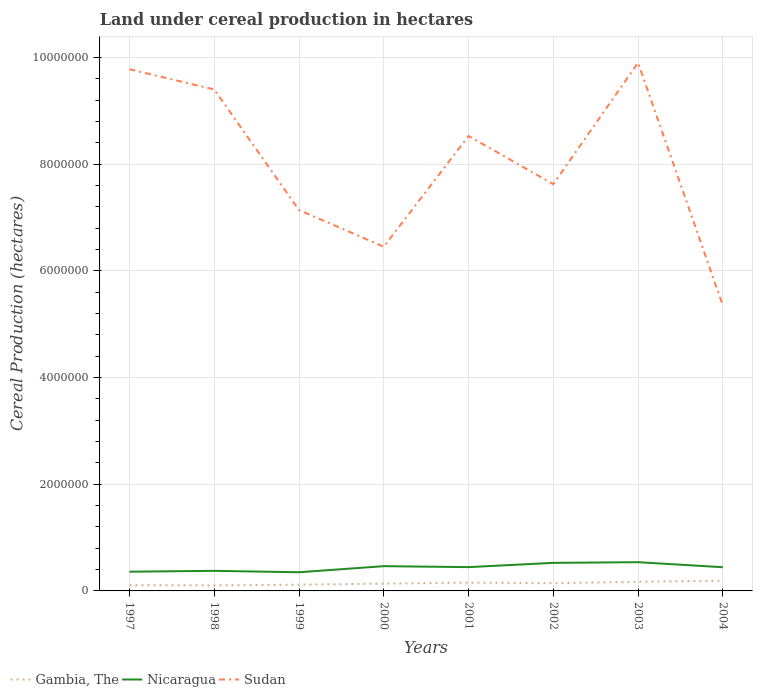How many different coloured lines are there?
Keep it short and to the point. 3. Does the line corresponding to Sudan intersect with the line corresponding to Gambia, The?
Offer a terse response. No. Is the number of lines equal to the number of legend labels?
Ensure brevity in your answer.  Yes. Across all years, what is the maximum land under cereal production in Nicaragua?
Provide a succinct answer. 3.50e+05. In which year was the land under cereal production in Gambia, The maximum?
Provide a short and direct response. 1998. What is the total land under cereal production in Gambia, The in the graph?
Provide a short and direct response. -5.24e+04. What is the difference between the highest and the second highest land under cereal production in Gambia, The?
Ensure brevity in your answer.  8.74e+04. Is the land under cereal production in Gambia, The strictly greater than the land under cereal production in Sudan over the years?
Give a very brief answer. Yes. How many years are there in the graph?
Provide a short and direct response. 8. Are the values on the major ticks of Y-axis written in scientific E-notation?
Ensure brevity in your answer.  No. Does the graph contain any zero values?
Provide a short and direct response. No. Does the graph contain grids?
Your answer should be compact. Yes. What is the title of the graph?
Provide a short and direct response. Land under cereal production in hectares. Does "Mexico" appear as one of the legend labels in the graph?
Provide a succinct answer. No. What is the label or title of the X-axis?
Ensure brevity in your answer.  Years. What is the label or title of the Y-axis?
Ensure brevity in your answer.  Cereal Production (hectares). What is the Cereal Production (hectares) in Gambia, The in 1997?
Give a very brief answer. 1.08e+05. What is the Cereal Production (hectares) of Nicaragua in 1997?
Provide a short and direct response. 3.60e+05. What is the Cereal Production (hectares) of Sudan in 1997?
Offer a terse response. 9.78e+06. What is the Cereal Production (hectares) of Gambia, The in 1998?
Keep it short and to the point. 1.04e+05. What is the Cereal Production (hectares) of Nicaragua in 1998?
Your answer should be very brief. 3.76e+05. What is the Cereal Production (hectares) of Sudan in 1998?
Keep it short and to the point. 9.40e+06. What is the Cereal Production (hectares) of Gambia, The in 1999?
Make the answer very short. 1.17e+05. What is the Cereal Production (hectares) in Nicaragua in 1999?
Make the answer very short. 3.50e+05. What is the Cereal Production (hectares) of Sudan in 1999?
Make the answer very short. 7.14e+06. What is the Cereal Production (hectares) of Gambia, The in 2000?
Offer a very short reply. 1.36e+05. What is the Cereal Production (hectares) of Nicaragua in 2000?
Your answer should be compact. 4.64e+05. What is the Cereal Production (hectares) of Sudan in 2000?
Ensure brevity in your answer.  6.45e+06. What is the Cereal Production (hectares) of Gambia, The in 2001?
Offer a terse response. 1.56e+05. What is the Cereal Production (hectares) of Nicaragua in 2001?
Keep it short and to the point. 4.46e+05. What is the Cereal Production (hectares) in Sudan in 2001?
Offer a terse response. 8.53e+06. What is the Cereal Production (hectares) of Gambia, The in 2002?
Your response must be concise. 1.45e+05. What is the Cereal Production (hectares) in Nicaragua in 2002?
Make the answer very short. 5.26e+05. What is the Cereal Production (hectares) in Sudan in 2002?
Provide a short and direct response. 7.62e+06. What is the Cereal Production (hectares) in Gambia, The in 2003?
Ensure brevity in your answer.  1.71e+05. What is the Cereal Production (hectares) in Nicaragua in 2003?
Your answer should be very brief. 5.39e+05. What is the Cereal Production (hectares) in Sudan in 2003?
Ensure brevity in your answer.  9.90e+06. What is the Cereal Production (hectares) of Gambia, The in 2004?
Provide a short and direct response. 1.91e+05. What is the Cereal Production (hectares) of Nicaragua in 2004?
Provide a succinct answer. 4.44e+05. What is the Cereal Production (hectares) of Sudan in 2004?
Offer a very short reply. 5.35e+06. Across all years, what is the maximum Cereal Production (hectares) in Gambia, The?
Give a very brief answer. 1.91e+05. Across all years, what is the maximum Cereal Production (hectares) of Nicaragua?
Make the answer very short. 5.39e+05. Across all years, what is the maximum Cereal Production (hectares) of Sudan?
Give a very brief answer. 9.90e+06. Across all years, what is the minimum Cereal Production (hectares) of Gambia, The?
Provide a succinct answer. 1.04e+05. Across all years, what is the minimum Cereal Production (hectares) in Nicaragua?
Your response must be concise. 3.50e+05. Across all years, what is the minimum Cereal Production (hectares) in Sudan?
Provide a succinct answer. 5.35e+06. What is the total Cereal Production (hectares) in Gambia, The in the graph?
Provide a short and direct response. 1.13e+06. What is the total Cereal Production (hectares) of Nicaragua in the graph?
Your answer should be very brief. 3.51e+06. What is the total Cereal Production (hectares) in Sudan in the graph?
Keep it short and to the point. 6.42e+07. What is the difference between the Cereal Production (hectares) of Gambia, The in 1997 and that in 1998?
Offer a very short reply. 4112. What is the difference between the Cereal Production (hectares) of Nicaragua in 1997 and that in 1998?
Keep it short and to the point. -1.60e+04. What is the difference between the Cereal Production (hectares) in Sudan in 1997 and that in 1998?
Keep it short and to the point. 3.79e+05. What is the difference between the Cereal Production (hectares) of Gambia, The in 1997 and that in 1999?
Keep it short and to the point. -9125. What is the difference between the Cereal Production (hectares) of Nicaragua in 1997 and that in 1999?
Offer a very short reply. 1.04e+04. What is the difference between the Cereal Production (hectares) in Sudan in 1997 and that in 1999?
Keep it short and to the point. 2.64e+06. What is the difference between the Cereal Production (hectares) in Gambia, The in 1997 and that in 2000?
Your answer should be compact. -2.80e+04. What is the difference between the Cereal Production (hectares) of Nicaragua in 1997 and that in 2000?
Your answer should be compact. -1.04e+05. What is the difference between the Cereal Production (hectares) in Sudan in 1997 and that in 2000?
Your answer should be very brief. 3.33e+06. What is the difference between the Cereal Production (hectares) in Gambia, The in 1997 and that in 2001?
Your response must be concise. -4.83e+04. What is the difference between the Cereal Production (hectares) in Nicaragua in 1997 and that in 2001?
Your answer should be very brief. -8.57e+04. What is the difference between the Cereal Production (hectares) in Sudan in 1997 and that in 2001?
Ensure brevity in your answer.  1.25e+06. What is the difference between the Cereal Production (hectares) in Gambia, The in 1997 and that in 2002?
Your answer should be very brief. -3.71e+04. What is the difference between the Cereal Production (hectares) of Nicaragua in 1997 and that in 2002?
Ensure brevity in your answer.  -1.66e+05. What is the difference between the Cereal Production (hectares) of Sudan in 1997 and that in 2002?
Offer a very short reply. 2.15e+06. What is the difference between the Cereal Production (hectares) in Gambia, The in 1997 and that in 2003?
Your response must be concise. -6.30e+04. What is the difference between the Cereal Production (hectares) of Nicaragua in 1997 and that in 2003?
Your answer should be very brief. -1.78e+05. What is the difference between the Cereal Production (hectares) in Sudan in 1997 and that in 2003?
Keep it short and to the point. -1.23e+05. What is the difference between the Cereal Production (hectares) of Gambia, The in 1997 and that in 2004?
Make the answer very short. -8.33e+04. What is the difference between the Cereal Production (hectares) in Nicaragua in 1997 and that in 2004?
Your answer should be compact. -8.40e+04. What is the difference between the Cereal Production (hectares) of Sudan in 1997 and that in 2004?
Offer a very short reply. 4.43e+06. What is the difference between the Cereal Production (hectares) in Gambia, The in 1998 and that in 1999?
Give a very brief answer. -1.32e+04. What is the difference between the Cereal Production (hectares) in Nicaragua in 1998 and that in 1999?
Your response must be concise. 2.64e+04. What is the difference between the Cereal Production (hectares) of Sudan in 1998 and that in 1999?
Your response must be concise. 2.26e+06. What is the difference between the Cereal Production (hectares) of Gambia, The in 1998 and that in 2000?
Give a very brief answer. -3.21e+04. What is the difference between the Cereal Production (hectares) of Nicaragua in 1998 and that in 2000?
Your answer should be very brief. -8.79e+04. What is the difference between the Cereal Production (hectares) in Sudan in 1998 and that in 2000?
Offer a very short reply. 2.95e+06. What is the difference between the Cereal Production (hectares) of Gambia, The in 1998 and that in 2001?
Ensure brevity in your answer.  -5.24e+04. What is the difference between the Cereal Production (hectares) in Nicaragua in 1998 and that in 2001?
Your answer should be compact. -6.97e+04. What is the difference between the Cereal Production (hectares) in Sudan in 1998 and that in 2001?
Keep it short and to the point. 8.72e+05. What is the difference between the Cereal Production (hectares) in Gambia, The in 1998 and that in 2002?
Offer a terse response. -4.12e+04. What is the difference between the Cereal Production (hectares) in Nicaragua in 1998 and that in 2002?
Make the answer very short. -1.50e+05. What is the difference between the Cereal Production (hectares) of Sudan in 1998 and that in 2002?
Your response must be concise. 1.77e+06. What is the difference between the Cereal Production (hectares) of Gambia, The in 1998 and that in 2003?
Make the answer very short. -6.71e+04. What is the difference between the Cereal Production (hectares) in Nicaragua in 1998 and that in 2003?
Give a very brief answer. -1.62e+05. What is the difference between the Cereal Production (hectares) in Sudan in 1998 and that in 2003?
Your response must be concise. -5.01e+05. What is the difference between the Cereal Production (hectares) in Gambia, The in 1998 and that in 2004?
Your answer should be compact. -8.74e+04. What is the difference between the Cereal Production (hectares) of Nicaragua in 1998 and that in 2004?
Ensure brevity in your answer.  -6.80e+04. What is the difference between the Cereal Production (hectares) of Sudan in 1998 and that in 2004?
Offer a terse response. 4.05e+06. What is the difference between the Cereal Production (hectares) of Gambia, The in 1999 and that in 2000?
Ensure brevity in your answer.  -1.88e+04. What is the difference between the Cereal Production (hectares) in Nicaragua in 1999 and that in 2000?
Keep it short and to the point. -1.14e+05. What is the difference between the Cereal Production (hectares) in Sudan in 1999 and that in 2000?
Offer a terse response. 6.87e+05. What is the difference between the Cereal Production (hectares) of Gambia, The in 1999 and that in 2001?
Provide a succinct answer. -3.92e+04. What is the difference between the Cereal Production (hectares) in Nicaragua in 1999 and that in 2001?
Offer a very short reply. -9.61e+04. What is the difference between the Cereal Production (hectares) in Sudan in 1999 and that in 2001?
Your answer should be very brief. -1.39e+06. What is the difference between the Cereal Production (hectares) of Gambia, The in 1999 and that in 2002?
Provide a short and direct response. -2.80e+04. What is the difference between the Cereal Production (hectares) in Nicaragua in 1999 and that in 2002?
Offer a terse response. -1.76e+05. What is the difference between the Cereal Production (hectares) in Sudan in 1999 and that in 2002?
Your answer should be very brief. -4.86e+05. What is the difference between the Cereal Production (hectares) of Gambia, The in 1999 and that in 2003?
Offer a very short reply. -5.39e+04. What is the difference between the Cereal Production (hectares) of Nicaragua in 1999 and that in 2003?
Offer a very short reply. -1.89e+05. What is the difference between the Cereal Production (hectares) in Sudan in 1999 and that in 2003?
Provide a succinct answer. -2.76e+06. What is the difference between the Cereal Production (hectares) of Gambia, The in 1999 and that in 2004?
Your answer should be very brief. -7.42e+04. What is the difference between the Cereal Production (hectares) of Nicaragua in 1999 and that in 2004?
Offer a very short reply. -9.44e+04. What is the difference between the Cereal Production (hectares) of Sudan in 1999 and that in 2004?
Your response must be concise. 1.79e+06. What is the difference between the Cereal Production (hectares) of Gambia, The in 2000 and that in 2001?
Your response must be concise. -2.04e+04. What is the difference between the Cereal Production (hectares) in Nicaragua in 2000 and that in 2001?
Offer a very short reply. 1.83e+04. What is the difference between the Cereal Production (hectares) in Sudan in 2000 and that in 2001?
Make the answer very short. -2.08e+06. What is the difference between the Cereal Production (hectares) in Gambia, The in 2000 and that in 2002?
Give a very brief answer. -9121. What is the difference between the Cereal Production (hectares) in Nicaragua in 2000 and that in 2002?
Provide a short and direct response. -6.16e+04. What is the difference between the Cereal Production (hectares) in Sudan in 2000 and that in 2002?
Keep it short and to the point. -1.17e+06. What is the difference between the Cereal Production (hectares) in Gambia, The in 2000 and that in 2003?
Ensure brevity in your answer.  -3.51e+04. What is the difference between the Cereal Production (hectares) in Nicaragua in 2000 and that in 2003?
Provide a succinct answer. -7.44e+04. What is the difference between the Cereal Production (hectares) of Sudan in 2000 and that in 2003?
Provide a succinct answer. -3.45e+06. What is the difference between the Cereal Production (hectares) of Gambia, The in 2000 and that in 2004?
Provide a succinct answer. -5.53e+04. What is the difference between the Cereal Production (hectares) in Nicaragua in 2000 and that in 2004?
Offer a terse response. 2.00e+04. What is the difference between the Cereal Production (hectares) of Sudan in 2000 and that in 2004?
Keep it short and to the point. 1.10e+06. What is the difference between the Cereal Production (hectares) in Gambia, The in 2001 and that in 2002?
Provide a succinct answer. 1.12e+04. What is the difference between the Cereal Production (hectares) of Nicaragua in 2001 and that in 2002?
Provide a succinct answer. -7.99e+04. What is the difference between the Cereal Production (hectares) in Sudan in 2001 and that in 2002?
Give a very brief answer. 9.03e+05. What is the difference between the Cereal Production (hectares) of Gambia, The in 2001 and that in 2003?
Offer a terse response. -1.47e+04. What is the difference between the Cereal Production (hectares) of Nicaragua in 2001 and that in 2003?
Your answer should be very brief. -9.27e+04. What is the difference between the Cereal Production (hectares) in Sudan in 2001 and that in 2003?
Offer a terse response. -1.37e+06. What is the difference between the Cereal Production (hectares) of Gambia, The in 2001 and that in 2004?
Provide a succinct answer. -3.50e+04. What is the difference between the Cereal Production (hectares) of Nicaragua in 2001 and that in 2004?
Ensure brevity in your answer.  1702. What is the difference between the Cereal Production (hectares) in Sudan in 2001 and that in 2004?
Ensure brevity in your answer.  3.18e+06. What is the difference between the Cereal Production (hectares) in Gambia, The in 2002 and that in 2003?
Offer a very short reply. -2.59e+04. What is the difference between the Cereal Production (hectares) of Nicaragua in 2002 and that in 2003?
Provide a succinct answer. -1.28e+04. What is the difference between the Cereal Production (hectares) of Sudan in 2002 and that in 2003?
Offer a very short reply. -2.28e+06. What is the difference between the Cereal Production (hectares) in Gambia, The in 2002 and that in 2004?
Give a very brief answer. -4.62e+04. What is the difference between the Cereal Production (hectares) in Nicaragua in 2002 and that in 2004?
Make the answer very short. 8.16e+04. What is the difference between the Cereal Production (hectares) in Sudan in 2002 and that in 2004?
Provide a short and direct response. 2.27e+06. What is the difference between the Cereal Production (hectares) of Gambia, The in 2003 and that in 2004?
Ensure brevity in your answer.  -2.02e+04. What is the difference between the Cereal Production (hectares) of Nicaragua in 2003 and that in 2004?
Provide a short and direct response. 9.44e+04. What is the difference between the Cereal Production (hectares) of Sudan in 2003 and that in 2004?
Offer a terse response. 4.55e+06. What is the difference between the Cereal Production (hectares) of Gambia, The in 1997 and the Cereal Production (hectares) of Nicaragua in 1998?
Keep it short and to the point. -2.68e+05. What is the difference between the Cereal Production (hectares) of Gambia, The in 1997 and the Cereal Production (hectares) of Sudan in 1998?
Provide a succinct answer. -9.29e+06. What is the difference between the Cereal Production (hectares) in Nicaragua in 1997 and the Cereal Production (hectares) in Sudan in 1998?
Ensure brevity in your answer.  -9.04e+06. What is the difference between the Cereal Production (hectares) in Gambia, The in 1997 and the Cereal Production (hectares) in Nicaragua in 1999?
Offer a terse response. -2.42e+05. What is the difference between the Cereal Production (hectares) in Gambia, The in 1997 and the Cereal Production (hectares) in Sudan in 1999?
Provide a succinct answer. -7.03e+06. What is the difference between the Cereal Production (hectares) in Nicaragua in 1997 and the Cereal Production (hectares) in Sudan in 1999?
Your answer should be compact. -6.78e+06. What is the difference between the Cereal Production (hectares) of Gambia, The in 1997 and the Cereal Production (hectares) of Nicaragua in 2000?
Provide a short and direct response. -3.56e+05. What is the difference between the Cereal Production (hectares) in Gambia, The in 1997 and the Cereal Production (hectares) in Sudan in 2000?
Your answer should be compact. -6.34e+06. What is the difference between the Cereal Production (hectares) of Nicaragua in 1997 and the Cereal Production (hectares) of Sudan in 2000?
Ensure brevity in your answer.  -6.09e+06. What is the difference between the Cereal Production (hectares) in Gambia, The in 1997 and the Cereal Production (hectares) in Nicaragua in 2001?
Keep it short and to the point. -3.38e+05. What is the difference between the Cereal Production (hectares) of Gambia, The in 1997 and the Cereal Production (hectares) of Sudan in 2001?
Offer a very short reply. -8.42e+06. What is the difference between the Cereal Production (hectares) of Nicaragua in 1997 and the Cereal Production (hectares) of Sudan in 2001?
Ensure brevity in your answer.  -8.17e+06. What is the difference between the Cereal Production (hectares) of Gambia, The in 1997 and the Cereal Production (hectares) of Nicaragua in 2002?
Make the answer very short. -4.18e+05. What is the difference between the Cereal Production (hectares) of Gambia, The in 1997 and the Cereal Production (hectares) of Sudan in 2002?
Your answer should be very brief. -7.52e+06. What is the difference between the Cereal Production (hectares) of Nicaragua in 1997 and the Cereal Production (hectares) of Sudan in 2002?
Keep it short and to the point. -7.26e+06. What is the difference between the Cereal Production (hectares) of Gambia, The in 1997 and the Cereal Production (hectares) of Nicaragua in 2003?
Your response must be concise. -4.31e+05. What is the difference between the Cereal Production (hectares) of Gambia, The in 1997 and the Cereal Production (hectares) of Sudan in 2003?
Offer a terse response. -9.79e+06. What is the difference between the Cereal Production (hectares) in Nicaragua in 1997 and the Cereal Production (hectares) in Sudan in 2003?
Your answer should be very brief. -9.54e+06. What is the difference between the Cereal Production (hectares) in Gambia, The in 1997 and the Cereal Production (hectares) in Nicaragua in 2004?
Offer a terse response. -3.36e+05. What is the difference between the Cereal Production (hectares) in Gambia, The in 1997 and the Cereal Production (hectares) in Sudan in 2004?
Your answer should be very brief. -5.24e+06. What is the difference between the Cereal Production (hectares) of Nicaragua in 1997 and the Cereal Production (hectares) of Sudan in 2004?
Offer a very short reply. -4.99e+06. What is the difference between the Cereal Production (hectares) of Gambia, The in 1998 and the Cereal Production (hectares) of Nicaragua in 1999?
Keep it short and to the point. -2.46e+05. What is the difference between the Cereal Production (hectares) in Gambia, The in 1998 and the Cereal Production (hectares) in Sudan in 1999?
Provide a short and direct response. -7.03e+06. What is the difference between the Cereal Production (hectares) in Nicaragua in 1998 and the Cereal Production (hectares) in Sudan in 1999?
Provide a short and direct response. -6.76e+06. What is the difference between the Cereal Production (hectares) in Gambia, The in 1998 and the Cereal Production (hectares) in Nicaragua in 2000?
Make the answer very short. -3.60e+05. What is the difference between the Cereal Production (hectares) in Gambia, The in 1998 and the Cereal Production (hectares) in Sudan in 2000?
Provide a short and direct response. -6.35e+06. What is the difference between the Cereal Production (hectares) of Nicaragua in 1998 and the Cereal Production (hectares) of Sudan in 2000?
Provide a succinct answer. -6.07e+06. What is the difference between the Cereal Production (hectares) of Gambia, The in 1998 and the Cereal Production (hectares) of Nicaragua in 2001?
Provide a short and direct response. -3.42e+05. What is the difference between the Cereal Production (hectares) in Gambia, The in 1998 and the Cereal Production (hectares) in Sudan in 2001?
Offer a terse response. -8.42e+06. What is the difference between the Cereal Production (hectares) of Nicaragua in 1998 and the Cereal Production (hectares) of Sudan in 2001?
Make the answer very short. -8.15e+06. What is the difference between the Cereal Production (hectares) in Gambia, The in 1998 and the Cereal Production (hectares) in Nicaragua in 2002?
Provide a succinct answer. -4.22e+05. What is the difference between the Cereal Production (hectares) of Gambia, The in 1998 and the Cereal Production (hectares) of Sudan in 2002?
Give a very brief answer. -7.52e+06. What is the difference between the Cereal Production (hectares) in Nicaragua in 1998 and the Cereal Production (hectares) in Sudan in 2002?
Make the answer very short. -7.25e+06. What is the difference between the Cereal Production (hectares) in Gambia, The in 1998 and the Cereal Production (hectares) in Nicaragua in 2003?
Provide a succinct answer. -4.35e+05. What is the difference between the Cereal Production (hectares) of Gambia, The in 1998 and the Cereal Production (hectares) of Sudan in 2003?
Offer a terse response. -9.80e+06. What is the difference between the Cereal Production (hectares) in Nicaragua in 1998 and the Cereal Production (hectares) in Sudan in 2003?
Keep it short and to the point. -9.52e+06. What is the difference between the Cereal Production (hectares) in Gambia, The in 1998 and the Cereal Production (hectares) in Nicaragua in 2004?
Give a very brief answer. -3.40e+05. What is the difference between the Cereal Production (hectares) of Gambia, The in 1998 and the Cereal Production (hectares) of Sudan in 2004?
Offer a very short reply. -5.25e+06. What is the difference between the Cereal Production (hectares) of Nicaragua in 1998 and the Cereal Production (hectares) of Sudan in 2004?
Offer a terse response. -4.97e+06. What is the difference between the Cereal Production (hectares) in Gambia, The in 1999 and the Cereal Production (hectares) in Nicaragua in 2000?
Your answer should be compact. -3.47e+05. What is the difference between the Cereal Production (hectares) of Gambia, The in 1999 and the Cereal Production (hectares) of Sudan in 2000?
Provide a succinct answer. -6.33e+06. What is the difference between the Cereal Production (hectares) of Nicaragua in 1999 and the Cereal Production (hectares) of Sudan in 2000?
Offer a terse response. -6.10e+06. What is the difference between the Cereal Production (hectares) of Gambia, The in 1999 and the Cereal Production (hectares) of Nicaragua in 2001?
Make the answer very short. -3.29e+05. What is the difference between the Cereal Production (hectares) of Gambia, The in 1999 and the Cereal Production (hectares) of Sudan in 2001?
Offer a terse response. -8.41e+06. What is the difference between the Cereal Production (hectares) of Nicaragua in 1999 and the Cereal Production (hectares) of Sudan in 2001?
Offer a terse response. -8.18e+06. What is the difference between the Cereal Production (hectares) in Gambia, The in 1999 and the Cereal Production (hectares) in Nicaragua in 2002?
Give a very brief answer. -4.09e+05. What is the difference between the Cereal Production (hectares) in Gambia, The in 1999 and the Cereal Production (hectares) in Sudan in 2002?
Offer a terse response. -7.51e+06. What is the difference between the Cereal Production (hectares) of Nicaragua in 1999 and the Cereal Production (hectares) of Sudan in 2002?
Offer a very short reply. -7.27e+06. What is the difference between the Cereal Production (hectares) in Gambia, The in 1999 and the Cereal Production (hectares) in Nicaragua in 2003?
Your response must be concise. -4.22e+05. What is the difference between the Cereal Production (hectares) in Gambia, The in 1999 and the Cereal Production (hectares) in Sudan in 2003?
Ensure brevity in your answer.  -9.78e+06. What is the difference between the Cereal Production (hectares) of Nicaragua in 1999 and the Cereal Production (hectares) of Sudan in 2003?
Your answer should be compact. -9.55e+06. What is the difference between the Cereal Production (hectares) in Gambia, The in 1999 and the Cereal Production (hectares) in Nicaragua in 2004?
Make the answer very short. -3.27e+05. What is the difference between the Cereal Production (hectares) in Gambia, The in 1999 and the Cereal Production (hectares) in Sudan in 2004?
Make the answer very short. -5.23e+06. What is the difference between the Cereal Production (hectares) in Nicaragua in 1999 and the Cereal Production (hectares) in Sudan in 2004?
Offer a terse response. -5.00e+06. What is the difference between the Cereal Production (hectares) of Gambia, The in 2000 and the Cereal Production (hectares) of Nicaragua in 2001?
Make the answer very short. -3.10e+05. What is the difference between the Cereal Production (hectares) of Gambia, The in 2000 and the Cereal Production (hectares) of Sudan in 2001?
Give a very brief answer. -8.39e+06. What is the difference between the Cereal Production (hectares) of Nicaragua in 2000 and the Cereal Production (hectares) of Sudan in 2001?
Ensure brevity in your answer.  -8.06e+06. What is the difference between the Cereal Production (hectares) of Gambia, The in 2000 and the Cereal Production (hectares) of Nicaragua in 2002?
Your answer should be very brief. -3.90e+05. What is the difference between the Cereal Production (hectares) of Gambia, The in 2000 and the Cereal Production (hectares) of Sudan in 2002?
Give a very brief answer. -7.49e+06. What is the difference between the Cereal Production (hectares) of Nicaragua in 2000 and the Cereal Production (hectares) of Sudan in 2002?
Make the answer very short. -7.16e+06. What is the difference between the Cereal Production (hectares) in Gambia, The in 2000 and the Cereal Production (hectares) in Nicaragua in 2003?
Provide a short and direct response. -4.03e+05. What is the difference between the Cereal Production (hectares) in Gambia, The in 2000 and the Cereal Production (hectares) in Sudan in 2003?
Make the answer very short. -9.76e+06. What is the difference between the Cereal Production (hectares) in Nicaragua in 2000 and the Cereal Production (hectares) in Sudan in 2003?
Give a very brief answer. -9.44e+06. What is the difference between the Cereal Production (hectares) in Gambia, The in 2000 and the Cereal Production (hectares) in Nicaragua in 2004?
Offer a terse response. -3.08e+05. What is the difference between the Cereal Production (hectares) of Gambia, The in 2000 and the Cereal Production (hectares) of Sudan in 2004?
Give a very brief answer. -5.21e+06. What is the difference between the Cereal Production (hectares) in Nicaragua in 2000 and the Cereal Production (hectares) in Sudan in 2004?
Provide a short and direct response. -4.89e+06. What is the difference between the Cereal Production (hectares) in Gambia, The in 2001 and the Cereal Production (hectares) in Nicaragua in 2002?
Your response must be concise. -3.70e+05. What is the difference between the Cereal Production (hectares) in Gambia, The in 2001 and the Cereal Production (hectares) in Sudan in 2002?
Your answer should be very brief. -7.47e+06. What is the difference between the Cereal Production (hectares) in Nicaragua in 2001 and the Cereal Production (hectares) in Sudan in 2002?
Your answer should be compact. -7.18e+06. What is the difference between the Cereal Production (hectares) of Gambia, The in 2001 and the Cereal Production (hectares) of Nicaragua in 2003?
Provide a short and direct response. -3.82e+05. What is the difference between the Cereal Production (hectares) in Gambia, The in 2001 and the Cereal Production (hectares) in Sudan in 2003?
Give a very brief answer. -9.74e+06. What is the difference between the Cereal Production (hectares) of Nicaragua in 2001 and the Cereal Production (hectares) of Sudan in 2003?
Make the answer very short. -9.45e+06. What is the difference between the Cereal Production (hectares) of Gambia, The in 2001 and the Cereal Production (hectares) of Nicaragua in 2004?
Your response must be concise. -2.88e+05. What is the difference between the Cereal Production (hectares) in Gambia, The in 2001 and the Cereal Production (hectares) in Sudan in 2004?
Give a very brief answer. -5.19e+06. What is the difference between the Cereal Production (hectares) of Nicaragua in 2001 and the Cereal Production (hectares) of Sudan in 2004?
Keep it short and to the point. -4.90e+06. What is the difference between the Cereal Production (hectares) of Gambia, The in 2002 and the Cereal Production (hectares) of Nicaragua in 2003?
Your response must be concise. -3.94e+05. What is the difference between the Cereal Production (hectares) of Gambia, The in 2002 and the Cereal Production (hectares) of Sudan in 2003?
Provide a succinct answer. -9.75e+06. What is the difference between the Cereal Production (hectares) of Nicaragua in 2002 and the Cereal Production (hectares) of Sudan in 2003?
Provide a succinct answer. -9.37e+06. What is the difference between the Cereal Production (hectares) in Gambia, The in 2002 and the Cereal Production (hectares) in Nicaragua in 2004?
Keep it short and to the point. -2.99e+05. What is the difference between the Cereal Production (hectares) in Gambia, The in 2002 and the Cereal Production (hectares) in Sudan in 2004?
Offer a terse response. -5.20e+06. What is the difference between the Cereal Production (hectares) of Nicaragua in 2002 and the Cereal Production (hectares) of Sudan in 2004?
Make the answer very short. -4.82e+06. What is the difference between the Cereal Production (hectares) of Gambia, The in 2003 and the Cereal Production (hectares) of Nicaragua in 2004?
Offer a very short reply. -2.73e+05. What is the difference between the Cereal Production (hectares) of Gambia, The in 2003 and the Cereal Production (hectares) of Sudan in 2004?
Keep it short and to the point. -5.18e+06. What is the difference between the Cereal Production (hectares) of Nicaragua in 2003 and the Cereal Production (hectares) of Sudan in 2004?
Ensure brevity in your answer.  -4.81e+06. What is the average Cereal Production (hectares) of Gambia, The per year?
Ensure brevity in your answer.  1.41e+05. What is the average Cereal Production (hectares) in Nicaragua per year?
Provide a succinct answer. 4.38e+05. What is the average Cereal Production (hectares) of Sudan per year?
Ensure brevity in your answer.  8.02e+06. In the year 1997, what is the difference between the Cereal Production (hectares) in Gambia, The and Cereal Production (hectares) in Nicaragua?
Ensure brevity in your answer.  -2.52e+05. In the year 1997, what is the difference between the Cereal Production (hectares) in Gambia, The and Cereal Production (hectares) in Sudan?
Keep it short and to the point. -9.67e+06. In the year 1997, what is the difference between the Cereal Production (hectares) of Nicaragua and Cereal Production (hectares) of Sudan?
Your answer should be compact. -9.42e+06. In the year 1998, what is the difference between the Cereal Production (hectares) in Gambia, The and Cereal Production (hectares) in Nicaragua?
Keep it short and to the point. -2.72e+05. In the year 1998, what is the difference between the Cereal Production (hectares) of Gambia, The and Cereal Production (hectares) of Sudan?
Provide a short and direct response. -9.29e+06. In the year 1998, what is the difference between the Cereal Production (hectares) of Nicaragua and Cereal Production (hectares) of Sudan?
Give a very brief answer. -9.02e+06. In the year 1999, what is the difference between the Cereal Production (hectares) of Gambia, The and Cereal Production (hectares) of Nicaragua?
Your response must be concise. -2.33e+05. In the year 1999, what is the difference between the Cereal Production (hectares) in Gambia, The and Cereal Production (hectares) in Sudan?
Give a very brief answer. -7.02e+06. In the year 1999, what is the difference between the Cereal Production (hectares) in Nicaragua and Cereal Production (hectares) in Sudan?
Provide a short and direct response. -6.79e+06. In the year 2000, what is the difference between the Cereal Production (hectares) in Gambia, The and Cereal Production (hectares) in Nicaragua?
Give a very brief answer. -3.28e+05. In the year 2000, what is the difference between the Cereal Production (hectares) of Gambia, The and Cereal Production (hectares) of Sudan?
Offer a very short reply. -6.32e+06. In the year 2000, what is the difference between the Cereal Production (hectares) in Nicaragua and Cereal Production (hectares) in Sudan?
Ensure brevity in your answer.  -5.99e+06. In the year 2001, what is the difference between the Cereal Production (hectares) in Gambia, The and Cereal Production (hectares) in Nicaragua?
Provide a short and direct response. -2.90e+05. In the year 2001, what is the difference between the Cereal Production (hectares) of Gambia, The and Cereal Production (hectares) of Sudan?
Provide a succinct answer. -8.37e+06. In the year 2001, what is the difference between the Cereal Production (hectares) of Nicaragua and Cereal Production (hectares) of Sudan?
Offer a very short reply. -8.08e+06. In the year 2002, what is the difference between the Cereal Production (hectares) in Gambia, The and Cereal Production (hectares) in Nicaragua?
Give a very brief answer. -3.81e+05. In the year 2002, what is the difference between the Cereal Production (hectares) of Gambia, The and Cereal Production (hectares) of Sudan?
Offer a very short reply. -7.48e+06. In the year 2002, what is the difference between the Cereal Production (hectares) of Nicaragua and Cereal Production (hectares) of Sudan?
Give a very brief answer. -7.10e+06. In the year 2003, what is the difference between the Cereal Production (hectares) in Gambia, The and Cereal Production (hectares) in Nicaragua?
Your answer should be very brief. -3.68e+05. In the year 2003, what is the difference between the Cereal Production (hectares) of Gambia, The and Cereal Production (hectares) of Sudan?
Your answer should be very brief. -9.73e+06. In the year 2003, what is the difference between the Cereal Production (hectares) in Nicaragua and Cereal Production (hectares) in Sudan?
Offer a very short reply. -9.36e+06. In the year 2004, what is the difference between the Cereal Production (hectares) of Gambia, The and Cereal Production (hectares) of Nicaragua?
Your answer should be very brief. -2.53e+05. In the year 2004, what is the difference between the Cereal Production (hectares) in Gambia, The and Cereal Production (hectares) in Sudan?
Give a very brief answer. -5.16e+06. In the year 2004, what is the difference between the Cereal Production (hectares) of Nicaragua and Cereal Production (hectares) of Sudan?
Your response must be concise. -4.91e+06. What is the ratio of the Cereal Production (hectares) in Gambia, The in 1997 to that in 1998?
Provide a succinct answer. 1.04. What is the ratio of the Cereal Production (hectares) of Nicaragua in 1997 to that in 1998?
Make the answer very short. 0.96. What is the ratio of the Cereal Production (hectares) in Sudan in 1997 to that in 1998?
Your response must be concise. 1.04. What is the ratio of the Cereal Production (hectares) of Gambia, The in 1997 to that in 1999?
Provide a short and direct response. 0.92. What is the ratio of the Cereal Production (hectares) in Nicaragua in 1997 to that in 1999?
Provide a short and direct response. 1.03. What is the ratio of the Cereal Production (hectares) in Sudan in 1997 to that in 1999?
Ensure brevity in your answer.  1.37. What is the ratio of the Cereal Production (hectares) in Gambia, The in 1997 to that in 2000?
Your answer should be compact. 0.79. What is the ratio of the Cereal Production (hectares) in Nicaragua in 1997 to that in 2000?
Give a very brief answer. 0.78. What is the ratio of the Cereal Production (hectares) in Sudan in 1997 to that in 2000?
Give a very brief answer. 1.52. What is the ratio of the Cereal Production (hectares) in Gambia, The in 1997 to that in 2001?
Give a very brief answer. 0.69. What is the ratio of the Cereal Production (hectares) in Nicaragua in 1997 to that in 2001?
Provide a succinct answer. 0.81. What is the ratio of the Cereal Production (hectares) in Sudan in 1997 to that in 2001?
Your response must be concise. 1.15. What is the ratio of the Cereal Production (hectares) of Gambia, The in 1997 to that in 2002?
Offer a very short reply. 0.74. What is the ratio of the Cereal Production (hectares) in Nicaragua in 1997 to that in 2002?
Your response must be concise. 0.69. What is the ratio of the Cereal Production (hectares) of Sudan in 1997 to that in 2002?
Keep it short and to the point. 1.28. What is the ratio of the Cereal Production (hectares) of Gambia, The in 1997 to that in 2003?
Ensure brevity in your answer.  0.63. What is the ratio of the Cereal Production (hectares) in Nicaragua in 1997 to that in 2003?
Offer a terse response. 0.67. What is the ratio of the Cereal Production (hectares) in Sudan in 1997 to that in 2003?
Provide a succinct answer. 0.99. What is the ratio of the Cereal Production (hectares) in Gambia, The in 1997 to that in 2004?
Your answer should be very brief. 0.56. What is the ratio of the Cereal Production (hectares) in Nicaragua in 1997 to that in 2004?
Your response must be concise. 0.81. What is the ratio of the Cereal Production (hectares) in Sudan in 1997 to that in 2004?
Your answer should be very brief. 1.83. What is the ratio of the Cereal Production (hectares) of Gambia, The in 1998 to that in 1999?
Your answer should be compact. 0.89. What is the ratio of the Cereal Production (hectares) in Nicaragua in 1998 to that in 1999?
Offer a very short reply. 1.08. What is the ratio of the Cereal Production (hectares) in Sudan in 1998 to that in 1999?
Ensure brevity in your answer.  1.32. What is the ratio of the Cereal Production (hectares) in Gambia, The in 1998 to that in 2000?
Give a very brief answer. 0.76. What is the ratio of the Cereal Production (hectares) of Nicaragua in 1998 to that in 2000?
Your response must be concise. 0.81. What is the ratio of the Cereal Production (hectares) in Sudan in 1998 to that in 2000?
Your response must be concise. 1.46. What is the ratio of the Cereal Production (hectares) in Gambia, The in 1998 to that in 2001?
Your answer should be very brief. 0.66. What is the ratio of the Cereal Production (hectares) in Nicaragua in 1998 to that in 2001?
Provide a succinct answer. 0.84. What is the ratio of the Cereal Production (hectares) of Sudan in 1998 to that in 2001?
Make the answer very short. 1.1. What is the ratio of the Cereal Production (hectares) of Gambia, The in 1998 to that in 2002?
Give a very brief answer. 0.72. What is the ratio of the Cereal Production (hectares) in Nicaragua in 1998 to that in 2002?
Your answer should be compact. 0.72. What is the ratio of the Cereal Production (hectares) in Sudan in 1998 to that in 2002?
Offer a terse response. 1.23. What is the ratio of the Cereal Production (hectares) of Gambia, The in 1998 to that in 2003?
Provide a succinct answer. 0.61. What is the ratio of the Cereal Production (hectares) in Nicaragua in 1998 to that in 2003?
Provide a short and direct response. 0.7. What is the ratio of the Cereal Production (hectares) of Sudan in 1998 to that in 2003?
Give a very brief answer. 0.95. What is the ratio of the Cereal Production (hectares) of Gambia, The in 1998 to that in 2004?
Keep it short and to the point. 0.54. What is the ratio of the Cereal Production (hectares) of Nicaragua in 1998 to that in 2004?
Provide a short and direct response. 0.85. What is the ratio of the Cereal Production (hectares) of Sudan in 1998 to that in 2004?
Ensure brevity in your answer.  1.76. What is the ratio of the Cereal Production (hectares) of Gambia, The in 1999 to that in 2000?
Your response must be concise. 0.86. What is the ratio of the Cereal Production (hectares) of Nicaragua in 1999 to that in 2000?
Your response must be concise. 0.75. What is the ratio of the Cereal Production (hectares) in Sudan in 1999 to that in 2000?
Your answer should be very brief. 1.11. What is the ratio of the Cereal Production (hectares) in Gambia, The in 1999 to that in 2001?
Make the answer very short. 0.75. What is the ratio of the Cereal Production (hectares) of Nicaragua in 1999 to that in 2001?
Provide a short and direct response. 0.78. What is the ratio of the Cereal Production (hectares) in Sudan in 1999 to that in 2001?
Provide a short and direct response. 0.84. What is the ratio of the Cereal Production (hectares) of Gambia, The in 1999 to that in 2002?
Ensure brevity in your answer.  0.81. What is the ratio of the Cereal Production (hectares) of Nicaragua in 1999 to that in 2002?
Ensure brevity in your answer.  0.67. What is the ratio of the Cereal Production (hectares) of Sudan in 1999 to that in 2002?
Your response must be concise. 0.94. What is the ratio of the Cereal Production (hectares) in Gambia, The in 1999 to that in 2003?
Provide a short and direct response. 0.68. What is the ratio of the Cereal Production (hectares) in Nicaragua in 1999 to that in 2003?
Provide a short and direct response. 0.65. What is the ratio of the Cereal Production (hectares) of Sudan in 1999 to that in 2003?
Give a very brief answer. 0.72. What is the ratio of the Cereal Production (hectares) in Gambia, The in 1999 to that in 2004?
Your response must be concise. 0.61. What is the ratio of the Cereal Production (hectares) in Nicaragua in 1999 to that in 2004?
Ensure brevity in your answer.  0.79. What is the ratio of the Cereal Production (hectares) in Sudan in 1999 to that in 2004?
Give a very brief answer. 1.33. What is the ratio of the Cereal Production (hectares) of Gambia, The in 2000 to that in 2001?
Ensure brevity in your answer.  0.87. What is the ratio of the Cereal Production (hectares) in Nicaragua in 2000 to that in 2001?
Keep it short and to the point. 1.04. What is the ratio of the Cereal Production (hectares) in Sudan in 2000 to that in 2001?
Offer a very short reply. 0.76. What is the ratio of the Cereal Production (hectares) of Gambia, The in 2000 to that in 2002?
Your answer should be compact. 0.94. What is the ratio of the Cereal Production (hectares) of Nicaragua in 2000 to that in 2002?
Keep it short and to the point. 0.88. What is the ratio of the Cereal Production (hectares) of Sudan in 2000 to that in 2002?
Offer a terse response. 0.85. What is the ratio of the Cereal Production (hectares) in Gambia, The in 2000 to that in 2003?
Provide a short and direct response. 0.79. What is the ratio of the Cereal Production (hectares) of Nicaragua in 2000 to that in 2003?
Your answer should be compact. 0.86. What is the ratio of the Cereal Production (hectares) of Sudan in 2000 to that in 2003?
Give a very brief answer. 0.65. What is the ratio of the Cereal Production (hectares) of Gambia, The in 2000 to that in 2004?
Keep it short and to the point. 0.71. What is the ratio of the Cereal Production (hectares) of Nicaragua in 2000 to that in 2004?
Ensure brevity in your answer.  1.04. What is the ratio of the Cereal Production (hectares) of Sudan in 2000 to that in 2004?
Provide a succinct answer. 1.21. What is the ratio of the Cereal Production (hectares) in Gambia, The in 2001 to that in 2002?
Give a very brief answer. 1.08. What is the ratio of the Cereal Production (hectares) in Nicaragua in 2001 to that in 2002?
Provide a short and direct response. 0.85. What is the ratio of the Cereal Production (hectares) in Sudan in 2001 to that in 2002?
Give a very brief answer. 1.12. What is the ratio of the Cereal Production (hectares) of Gambia, The in 2001 to that in 2003?
Offer a very short reply. 0.91. What is the ratio of the Cereal Production (hectares) of Nicaragua in 2001 to that in 2003?
Offer a very short reply. 0.83. What is the ratio of the Cereal Production (hectares) of Sudan in 2001 to that in 2003?
Your answer should be compact. 0.86. What is the ratio of the Cereal Production (hectares) in Gambia, The in 2001 to that in 2004?
Give a very brief answer. 0.82. What is the ratio of the Cereal Production (hectares) of Sudan in 2001 to that in 2004?
Your answer should be very brief. 1.59. What is the ratio of the Cereal Production (hectares) of Gambia, The in 2002 to that in 2003?
Offer a very short reply. 0.85. What is the ratio of the Cereal Production (hectares) in Nicaragua in 2002 to that in 2003?
Ensure brevity in your answer.  0.98. What is the ratio of the Cereal Production (hectares) of Sudan in 2002 to that in 2003?
Provide a succinct answer. 0.77. What is the ratio of the Cereal Production (hectares) of Gambia, The in 2002 to that in 2004?
Offer a terse response. 0.76. What is the ratio of the Cereal Production (hectares) in Nicaragua in 2002 to that in 2004?
Ensure brevity in your answer.  1.18. What is the ratio of the Cereal Production (hectares) in Sudan in 2002 to that in 2004?
Provide a short and direct response. 1.43. What is the ratio of the Cereal Production (hectares) in Gambia, The in 2003 to that in 2004?
Keep it short and to the point. 0.89. What is the ratio of the Cereal Production (hectares) of Nicaragua in 2003 to that in 2004?
Your answer should be compact. 1.21. What is the ratio of the Cereal Production (hectares) of Sudan in 2003 to that in 2004?
Ensure brevity in your answer.  1.85. What is the difference between the highest and the second highest Cereal Production (hectares) in Gambia, The?
Offer a very short reply. 2.02e+04. What is the difference between the highest and the second highest Cereal Production (hectares) of Nicaragua?
Keep it short and to the point. 1.28e+04. What is the difference between the highest and the second highest Cereal Production (hectares) of Sudan?
Give a very brief answer. 1.23e+05. What is the difference between the highest and the lowest Cereal Production (hectares) in Gambia, The?
Give a very brief answer. 8.74e+04. What is the difference between the highest and the lowest Cereal Production (hectares) of Nicaragua?
Offer a very short reply. 1.89e+05. What is the difference between the highest and the lowest Cereal Production (hectares) of Sudan?
Your answer should be compact. 4.55e+06. 